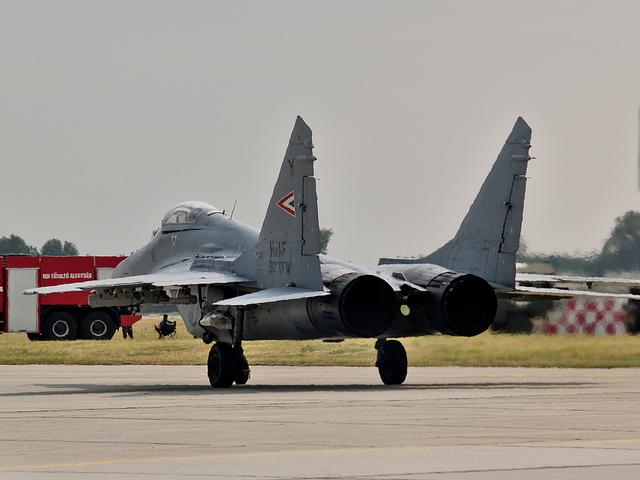Has this plane taken off?
Quick response, please. No. How many planes?
Give a very brief answer. 1. Is this a military plane?
Give a very brief answer. Yes. 